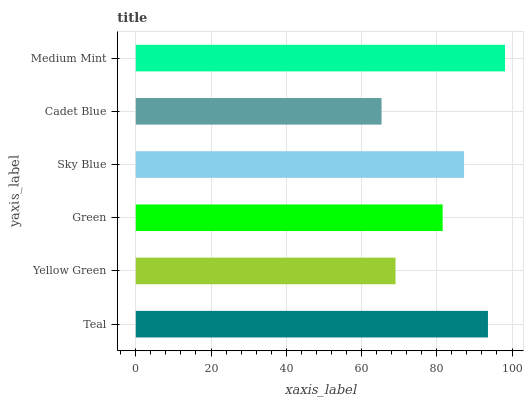Is Cadet Blue the minimum?
Answer yes or no. Yes. Is Medium Mint the maximum?
Answer yes or no. Yes. Is Yellow Green the minimum?
Answer yes or no. No. Is Yellow Green the maximum?
Answer yes or no. No. Is Teal greater than Yellow Green?
Answer yes or no. Yes. Is Yellow Green less than Teal?
Answer yes or no. Yes. Is Yellow Green greater than Teal?
Answer yes or no. No. Is Teal less than Yellow Green?
Answer yes or no. No. Is Sky Blue the high median?
Answer yes or no. Yes. Is Green the low median?
Answer yes or no. Yes. Is Teal the high median?
Answer yes or no. No. Is Sky Blue the low median?
Answer yes or no. No. 